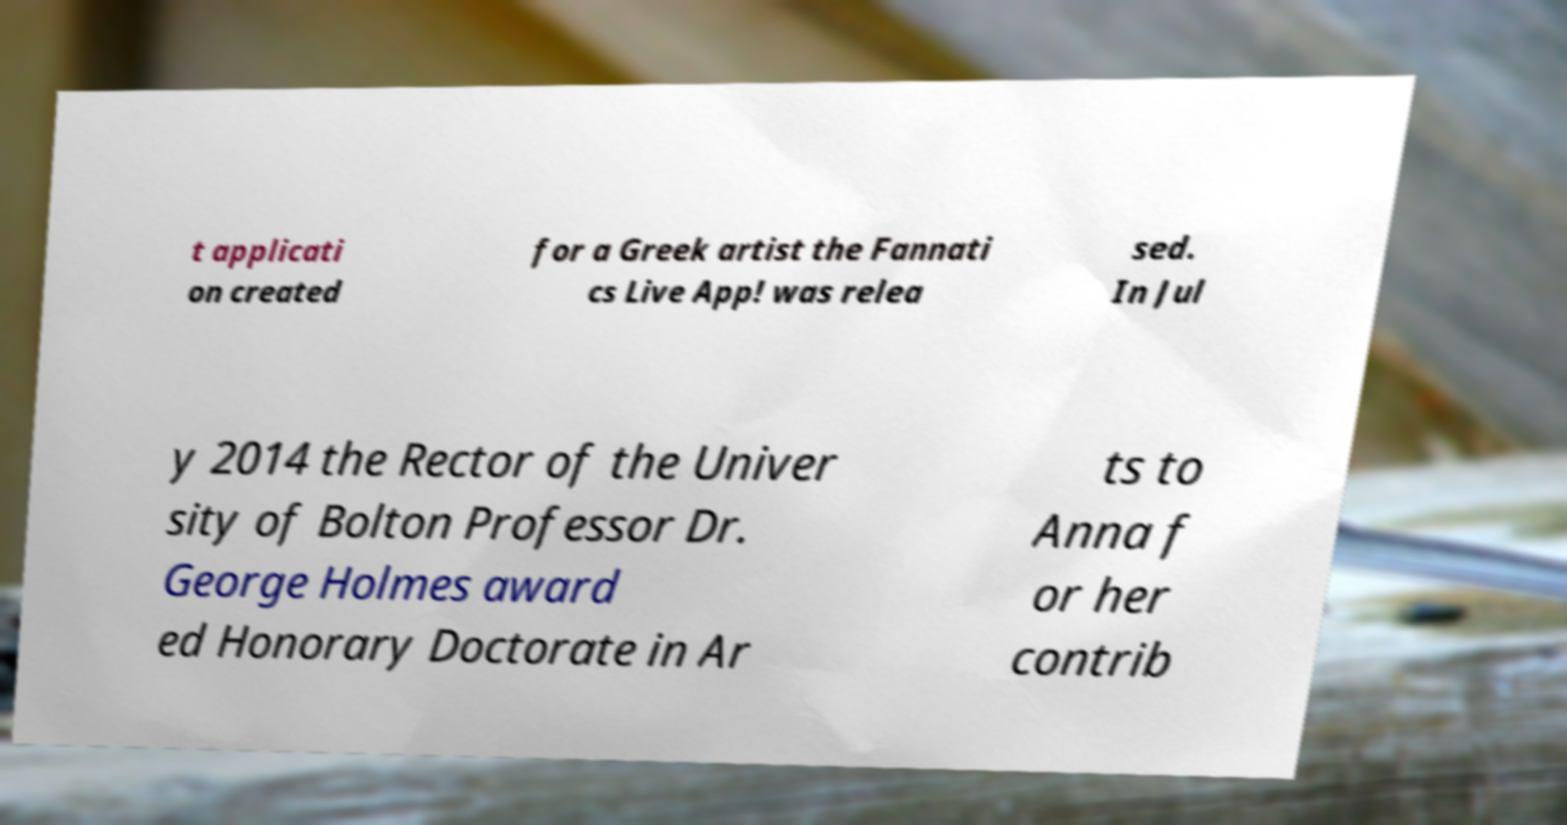Could you assist in decoding the text presented in this image and type it out clearly? t applicati on created for a Greek artist the Fannati cs Live App! was relea sed. In Jul y 2014 the Rector of the Univer sity of Bolton Professor Dr. George Holmes award ed Honorary Doctorate in Ar ts to Anna f or her contrib 